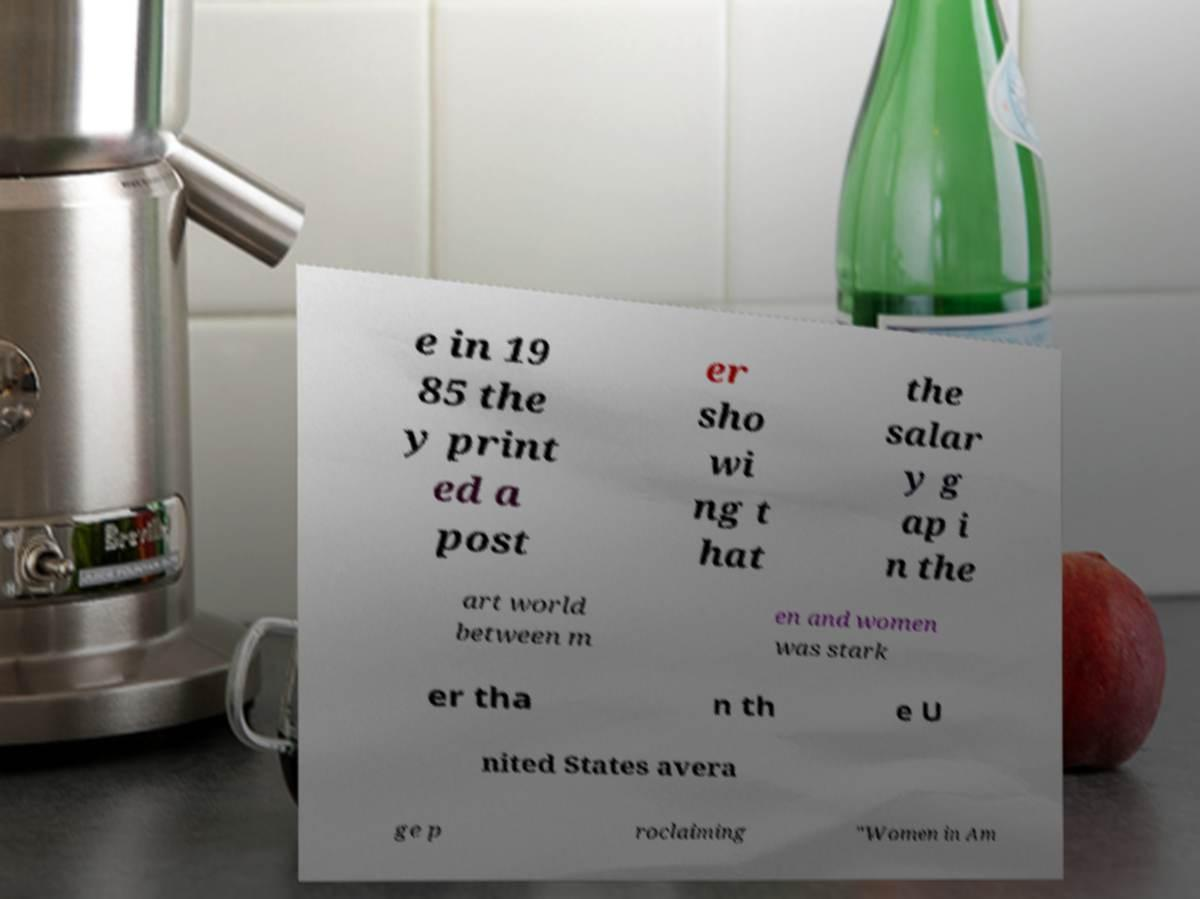Please identify and transcribe the text found in this image. e in 19 85 the y print ed a post er sho wi ng t hat the salar y g ap i n the art world between m en and women was stark er tha n th e U nited States avera ge p roclaiming "Women in Am 